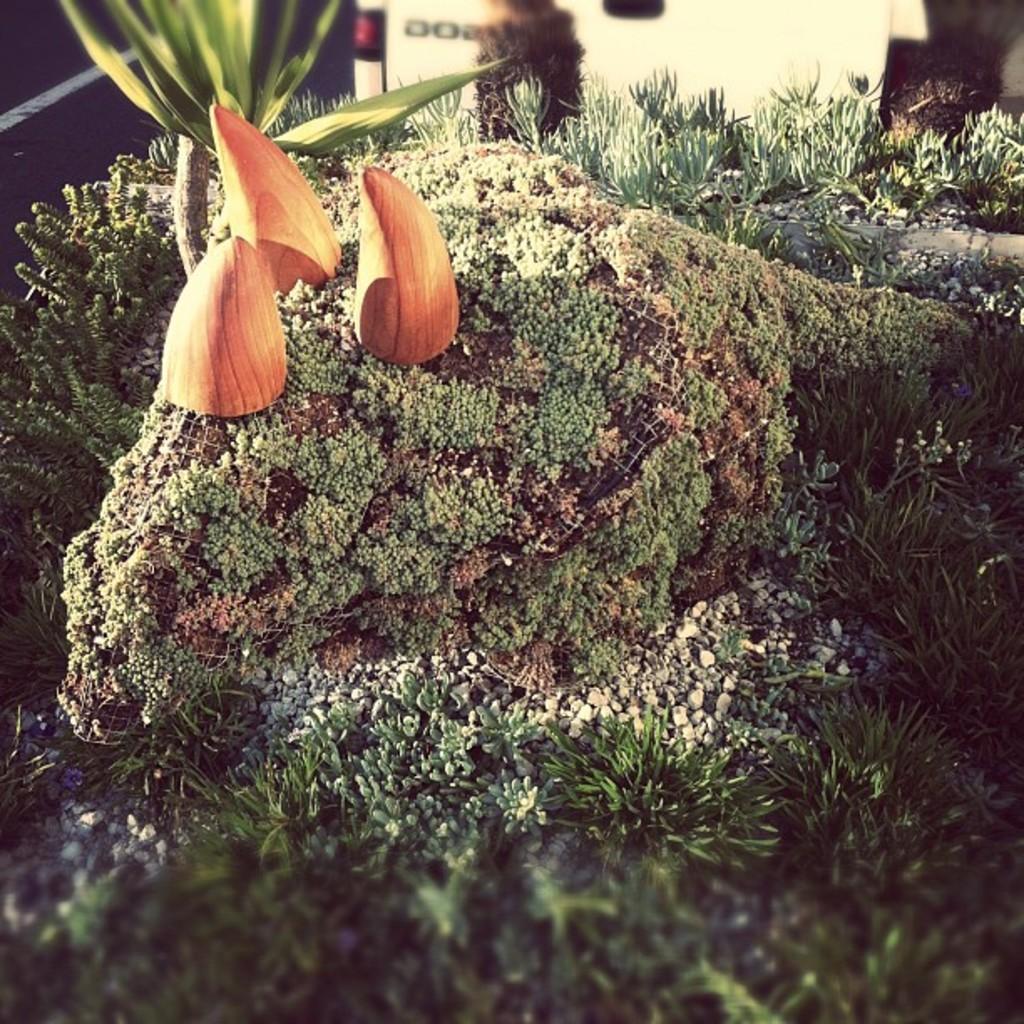In one or two sentences, can you explain what this image depicts? In this picture we can see there are plants, stones and some objects. Behind the plants there is the blurred background. 